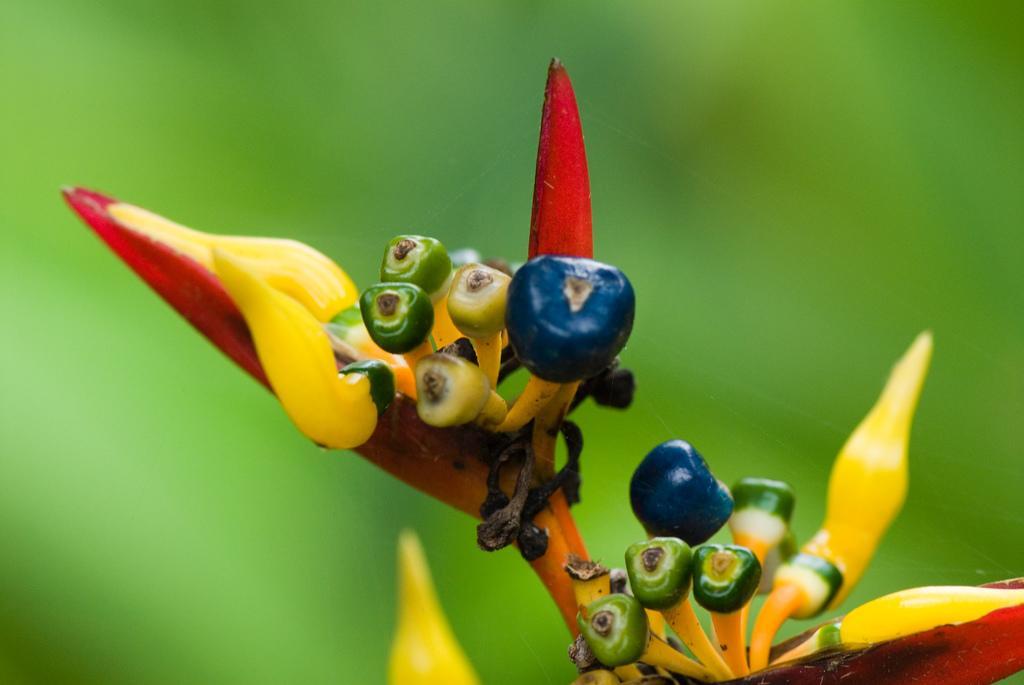In one or two sentences, can you explain what this image depicts? In the picture we can see a plant with flower buds which are green in color, some are blue, red, and yellow in color and behind it, we can see some plants which are green in color and not clearly visible. 